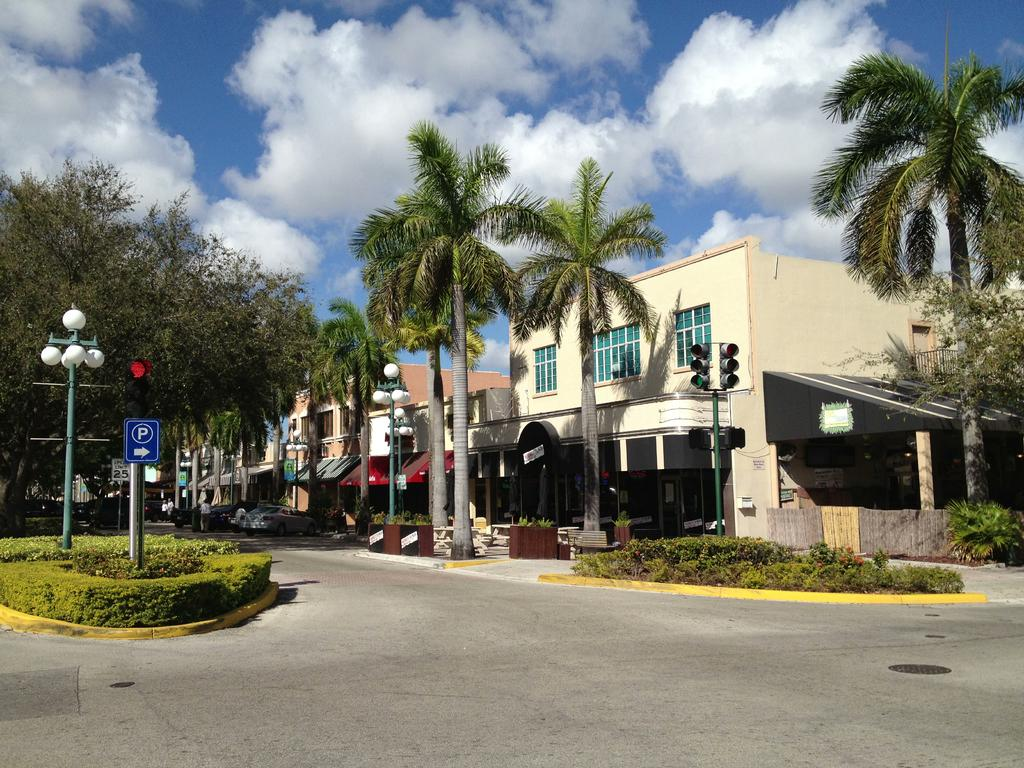What type of structures can be seen in the image? There are buildings in the image. What natural elements are present in the image? There are trees in the image. What are the vertical structures in the image used for? There are poles in the image, which are likely used for supporting lights or other fixtures. What type of illumination is present in the image? There are lights in the image. What is located on the left side of the image? There is a sign board on the left side of the image. What can be seen in the background of the image? There are clouds visible in the background of the image. What type of wood is used to construct the lift in the image? There is no lift present in the image, so the type of wood used for its construction cannot be determined. What type of lamp is hanging from the tree in the image? There is no lamp hanging from a tree in the image. 